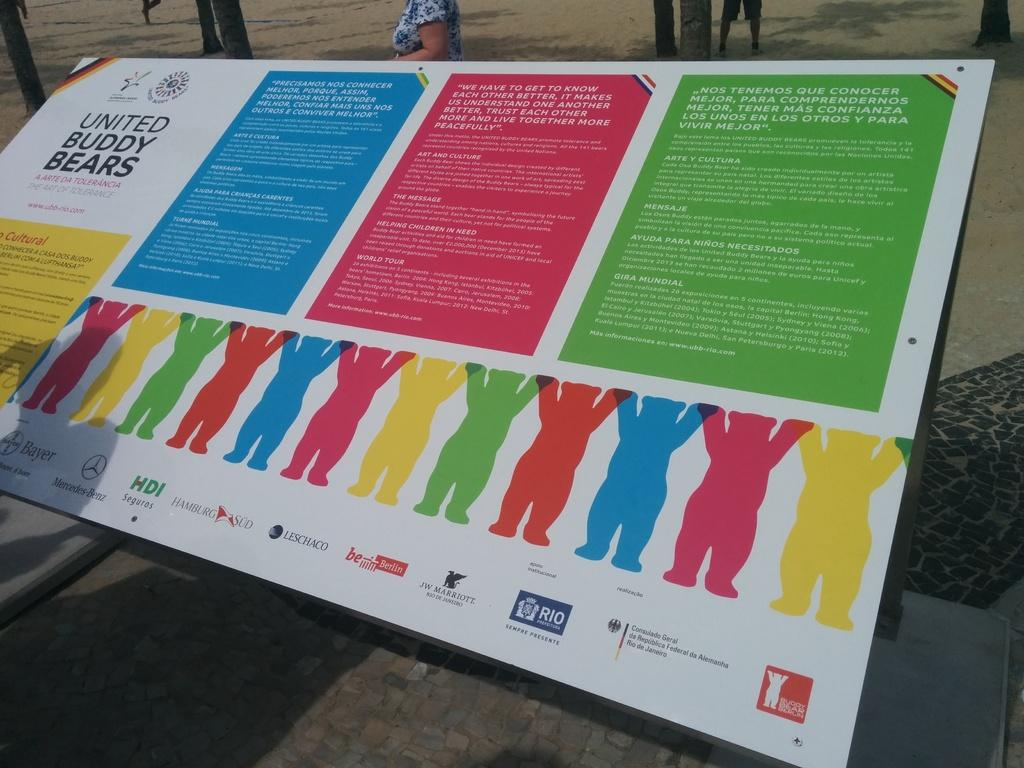<image>
Describe the image concisely. A multi colored poster for the united buddy bears. 